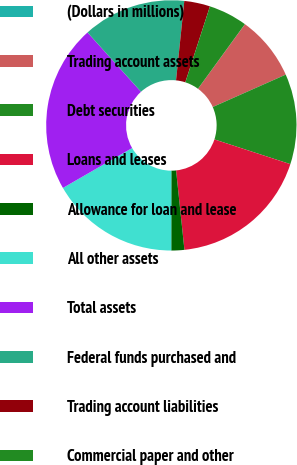<chart> <loc_0><loc_0><loc_500><loc_500><pie_chart><fcel>(Dollars in millions)<fcel>Trading account assets<fcel>Debt securities<fcel>Loans and leases<fcel>Allowance for loan and lease<fcel>All other assets<fcel>Total assets<fcel>Federal funds purchased and<fcel>Trading account liabilities<fcel>Commercial paper and other<nl><fcel>0.01%<fcel>8.34%<fcel>11.66%<fcel>18.32%<fcel>1.68%<fcel>16.66%<fcel>21.65%<fcel>13.33%<fcel>3.34%<fcel>5.01%<nl></chart> 